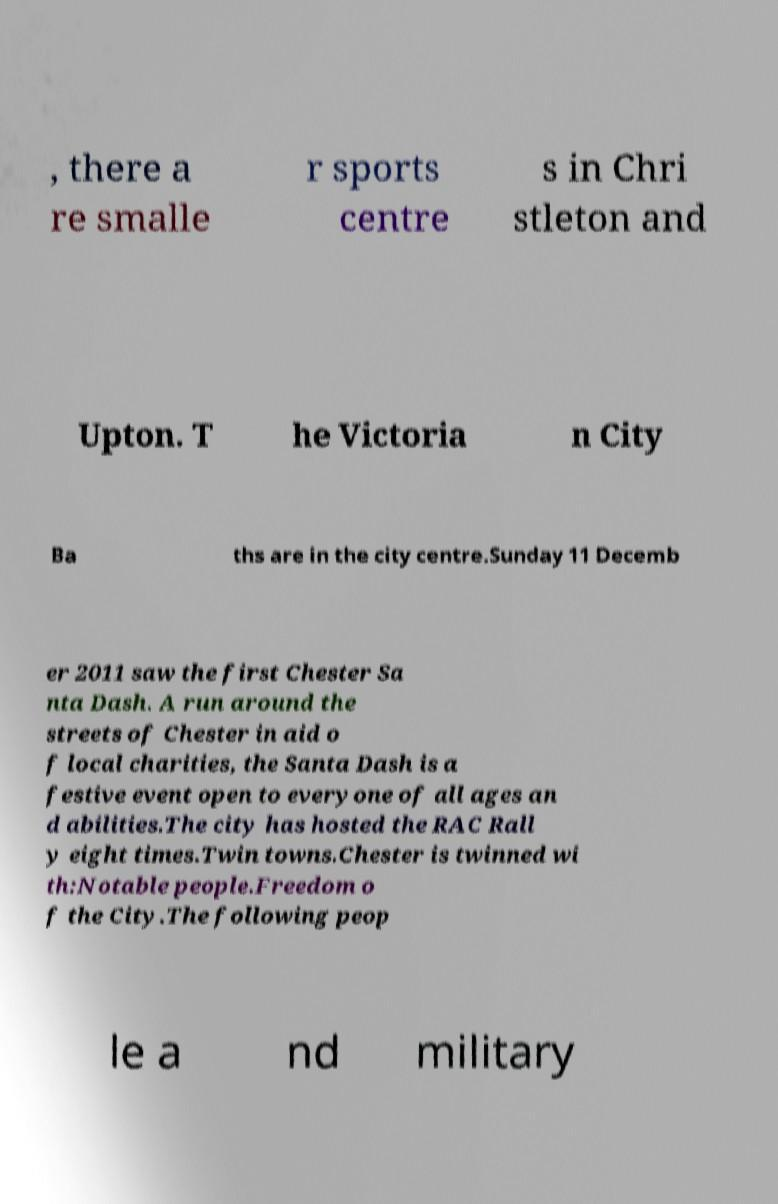Could you assist in decoding the text presented in this image and type it out clearly? , there a re smalle r sports centre s in Chri stleton and Upton. T he Victoria n City Ba ths are in the city centre.Sunday 11 Decemb er 2011 saw the first Chester Sa nta Dash. A run around the streets of Chester in aid o f local charities, the Santa Dash is a festive event open to everyone of all ages an d abilities.The city has hosted the RAC Rall y eight times.Twin towns.Chester is twinned wi th:Notable people.Freedom o f the City.The following peop le a nd military 